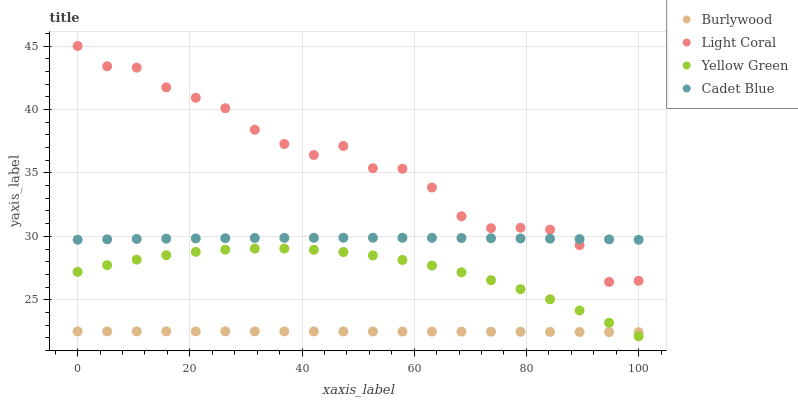Does Burlywood have the minimum area under the curve?
Answer yes or no. Yes. Does Light Coral have the maximum area under the curve?
Answer yes or no. Yes. Does Cadet Blue have the minimum area under the curve?
Answer yes or no. No. Does Cadet Blue have the maximum area under the curve?
Answer yes or no. No. Is Burlywood the smoothest?
Answer yes or no. Yes. Is Light Coral the roughest?
Answer yes or no. Yes. Is Cadet Blue the smoothest?
Answer yes or no. No. Is Cadet Blue the roughest?
Answer yes or no. No. Does Yellow Green have the lowest value?
Answer yes or no. Yes. Does Light Coral have the lowest value?
Answer yes or no. No. Does Light Coral have the highest value?
Answer yes or no. Yes. Does Cadet Blue have the highest value?
Answer yes or no. No. Is Yellow Green less than Light Coral?
Answer yes or no. Yes. Is Light Coral greater than Burlywood?
Answer yes or no. Yes. Does Light Coral intersect Cadet Blue?
Answer yes or no. Yes. Is Light Coral less than Cadet Blue?
Answer yes or no. No. Is Light Coral greater than Cadet Blue?
Answer yes or no. No. Does Yellow Green intersect Light Coral?
Answer yes or no. No. 